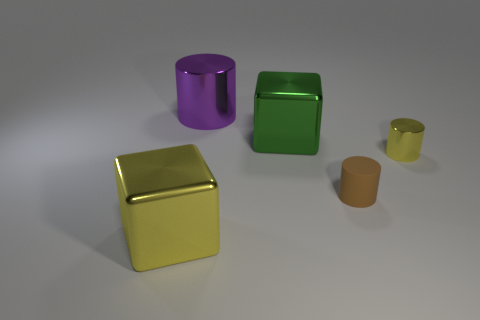Add 4 large purple metallic cylinders. How many objects exist? 9 Subtract all cylinders. How many objects are left? 2 Subtract all small yellow shiny things. Subtract all green things. How many objects are left? 3 Add 1 purple shiny things. How many purple shiny things are left? 2 Add 5 large purple cylinders. How many large purple cylinders exist? 6 Subtract 0 green cylinders. How many objects are left? 5 